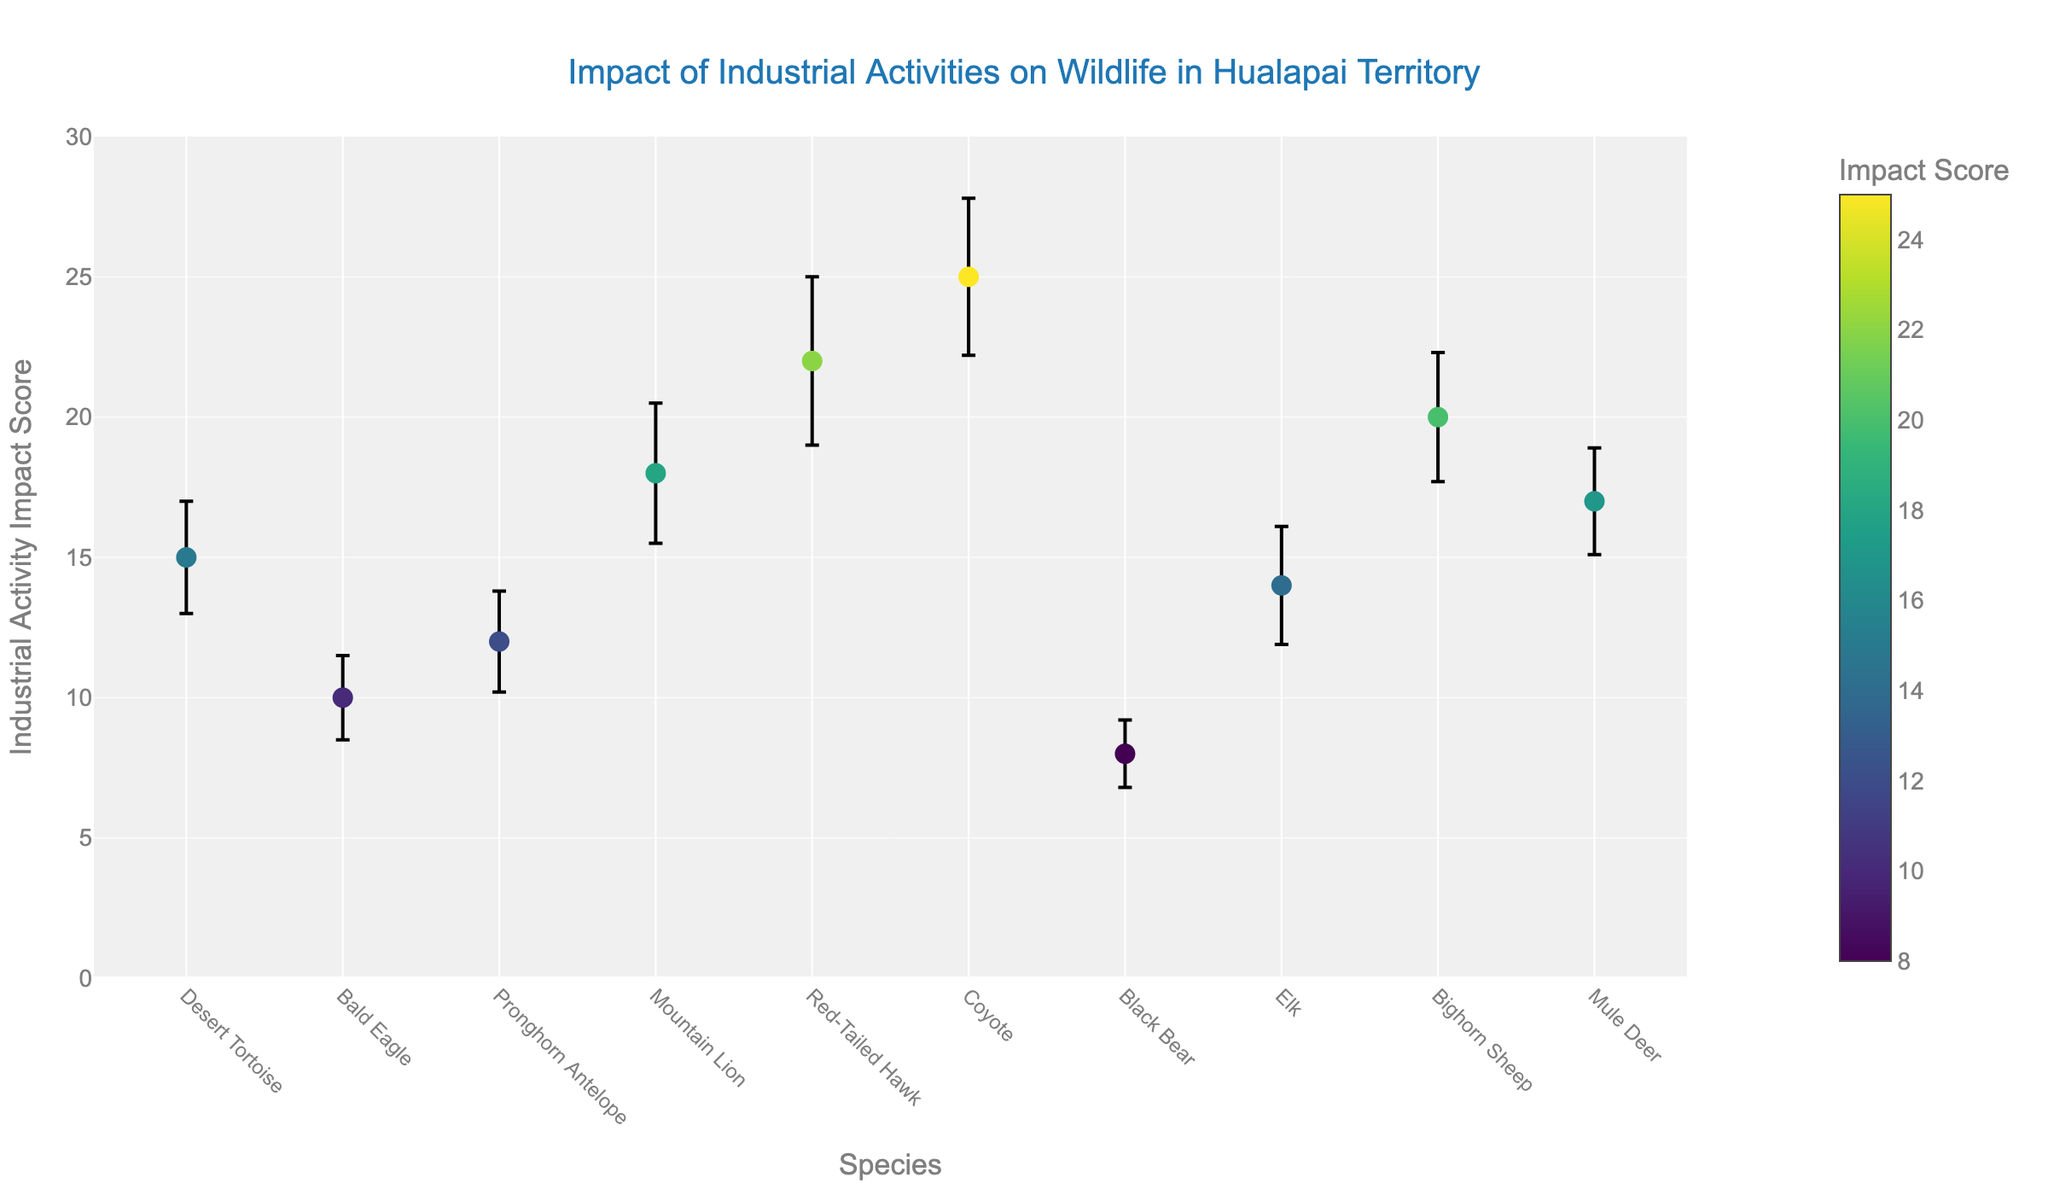How many species are included in the scatter plot? The scatter plot includes data points for different species, each represented by a unique position along the x-axis. By counting these unique positions, we can determine the number of species.
Answer: 10 What is the title of the scatter plot? The title of the figure is usually displayed at the top of the plot.
Answer: Impact of Industrial Activities on Wildlife in Hualapai Territory Which species has the highest Industrial Activity Impact Score? To find the species with the highest Impact Score, look for the highest data point along the y-axis.
Answer: Coyote What is the Standard Error for the Bald Eagle? The scatter plot shows error bars for each species; these error bars indicate the Standard Error. Referencing the Bald Eagle's position on the plot, the error bar is 1.5.
Answer: 1.5 What is the difference in Industrial Activity Impact Score between the Black Bear and the Red-Tailed Hawk? Find the y-values (Impact Scores) for both the Black Bear and the Red-Tailed Hawk and subtract the Black Bear's Impact Score from the Red-Tailed Hawk's. The Black Bear has a score of 8, and the Red-Tailed Hawk has 22, so the difference is 22 - 8.
Answer: 14 Which species is most affected by industrial activities in the Peach Springs region? Identify the species located in the Peach Springs region by referring to the location. Then, compare their Impact Scores to see which is highest. Both the Bald Eagle and Red-Tailed Hawk are in Peach Springs, and the Red-Tailed Hawk has a higher score.
Answer: Red-Tailed Hawk What is the average Industrial Activity Impact Score for all species present in the plot? Sum the Impact Scores of all species and then divide by the number of species. The sum is 15 + 10 + 12 + 18 + 22 + 25 + 8 + 14 + 20 + 17 = 161. Dividing by 10 yields an average of 16.1.
Answer: 16.1 Which species has the lowest Impact Score, and what is the value? Identify the data point with the lowest y-value to find the species with the least Industrial Activity Impact and note its value.
Answer: Black Bear, 8 What is the range of Industrial Activity Impact Scores displayed in the plot? The range is determined by the difference between the highest and lowest values. The highest Impact Score is 25 (Coyote), and the lowest is 8 (Black Bear). The range is 25 - 8.
Answer: 17 